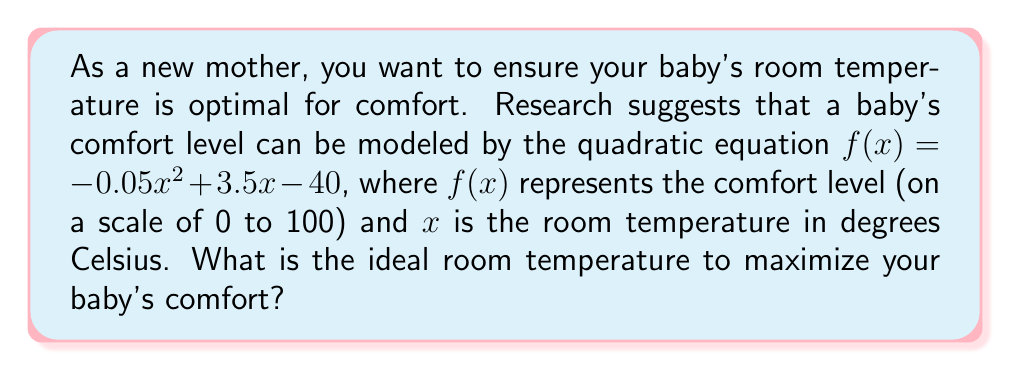What is the answer to this math problem? To find the optimal room temperature, we need to determine the maximum point of the quadratic function. The steps to solve this problem are:

1) The quadratic function is in the form $f(x) = ax^2 + bx + c$, where:
   $a = -0.05$
   $b = 3.5$
   $c = -40$

2) For a quadratic function, the x-coordinate of the vertex (which gives the maximum or minimum point) is given by the formula:

   $x = -\frac{b}{2a}$

3) Let's substitute our values:

   $x = -\frac{3.5}{2(-0.05)} = -\frac{3.5}{-0.1} = 35$

4) To verify this is a maximum (not a minimum), we can check that $a < 0$, which it is in this case.

5) Therefore, the ideal room temperature is 35°C.

6) We can calculate the comfort level at this temperature:

   $f(35) = -0.05(35)^2 + 3.5(35) - 40$
          $= -0.05(1225) + 122.5 - 40$
          $= -61.25 + 122.5 - 40$
          $= 21.25$

This means at 35°C, the baby's comfort level is at its maximum of 21.25 on the given scale.
Answer: The ideal room temperature to maximize the baby's comfort is 35°C. 